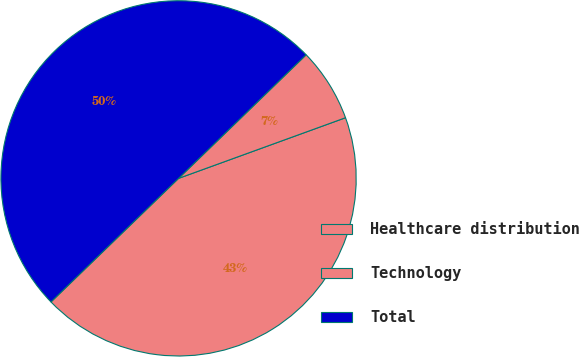Convert chart. <chart><loc_0><loc_0><loc_500><loc_500><pie_chart><fcel>Healthcare distribution<fcel>Technology<fcel>Total<nl><fcel>43.3%<fcel>6.7%<fcel>50.0%<nl></chart> 